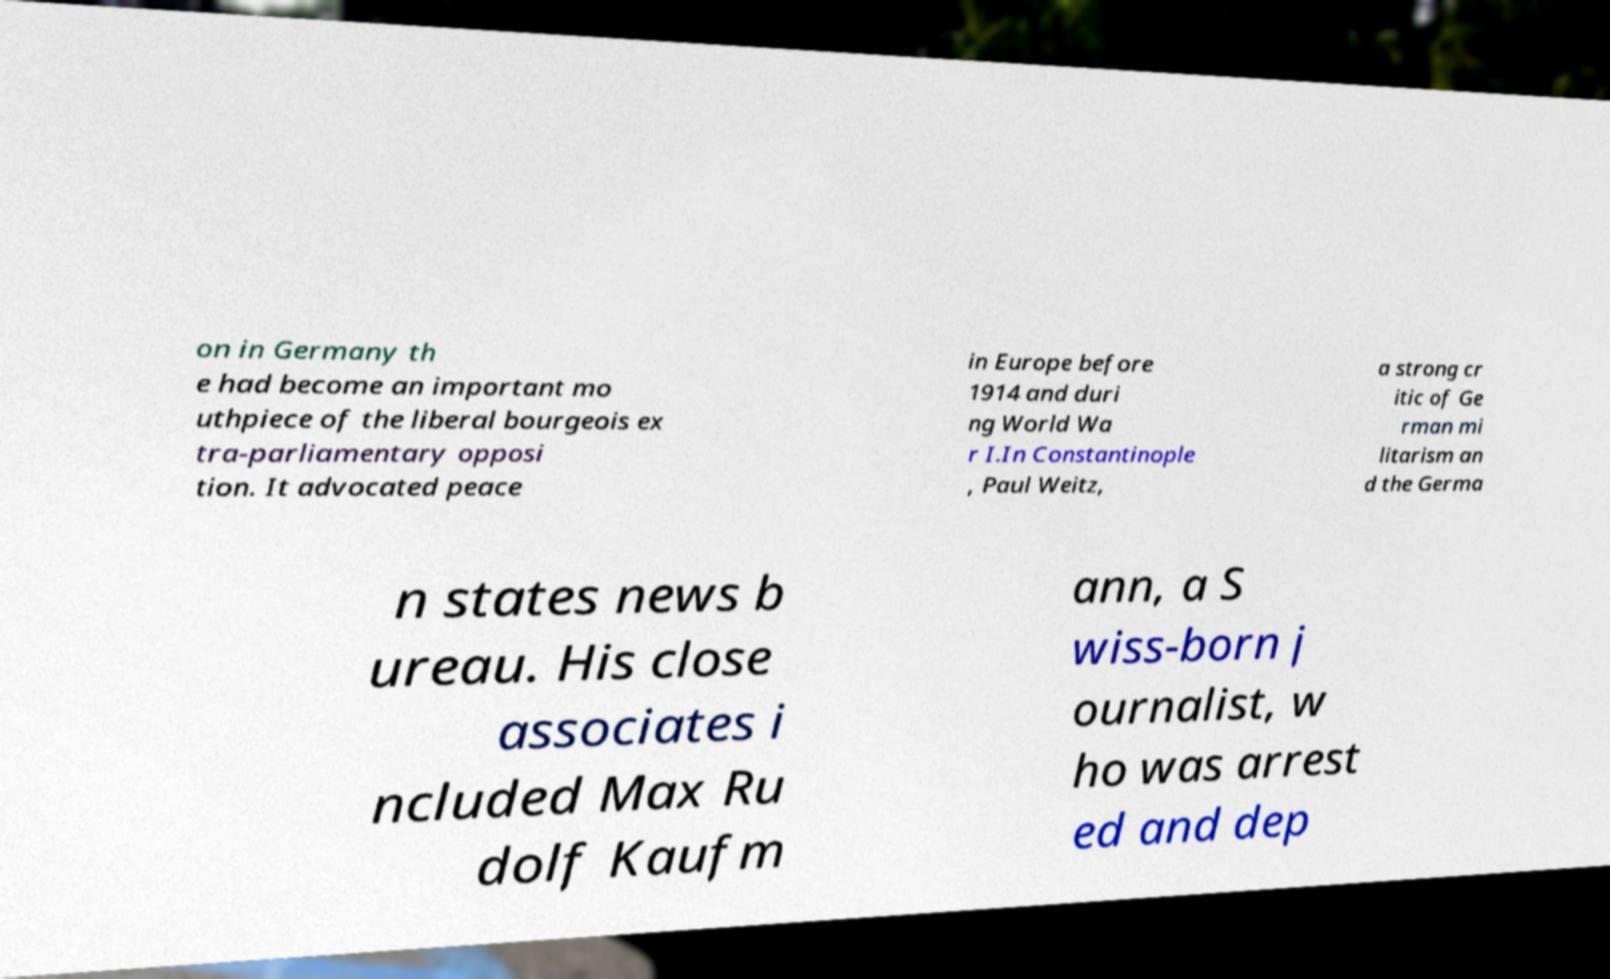I need the written content from this picture converted into text. Can you do that? on in Germany th e had become an important mo uthpiece of the liberal bourgeois ex tra-parliamentary opposi tion. It advocated peace in Europe before 1914 and duri ng World Wa r I.In Constantinople , Paul Weitz, a strong cr itic of Ge rman mi litarism an d the Germa n states news b ureau. His close associates i ncluded Max Ru dolf Kaufm ann, a S wiss-born j ournalist, w ho was arrest ed and dep 